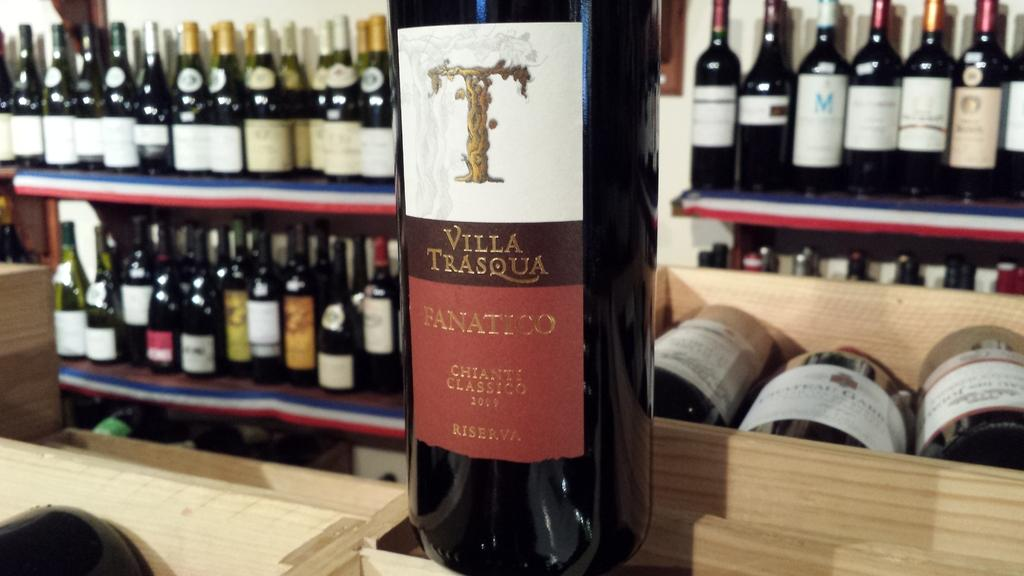<image>
Create a compact narrative representing the image presented. the word villa is on one of the bottles 